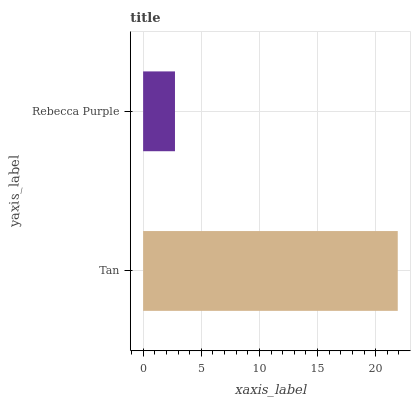Is Rebecca Purple the minimum?
Answer yes or no. Yes. Is Tan the maximum?
Answer yes or no. Yes. Is Rebecca Purple the maximum?
Answer yes or no. No. Is Tan greater than Rebecca Purple?
Answer yes or no. Yes. Is Rebecca Purple less than Tan?
Answer yes or no. Yes. Is Rebecca Purple greater than Tan?
Answer yes or no. No. Is Tan less than Rebecca Purple?
Answer yes or no. No. Is Tan the high median?
Answer yes or no. Yes. Is Rebecca Purple the low median?
Answer yes or no. Yes. Is Rebecca Purple the high median?
Answer yes or no. No. Is Tan the low median?
Answer yes or no. No. 